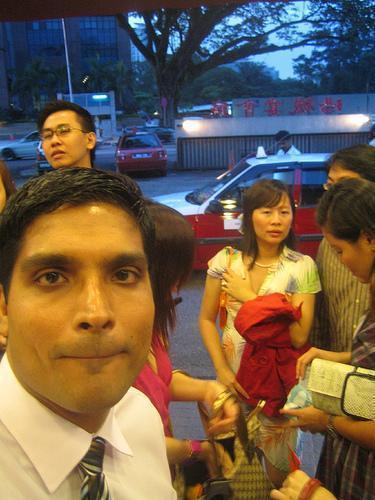What nationality does the man in the foreground appear to be?
Choose the correct response, then elucidate: 'Answer: answer
Rationale: rationale.'
Options: Indian, french, irish, german. Answer: indian.
Rationale: The people are indian. 